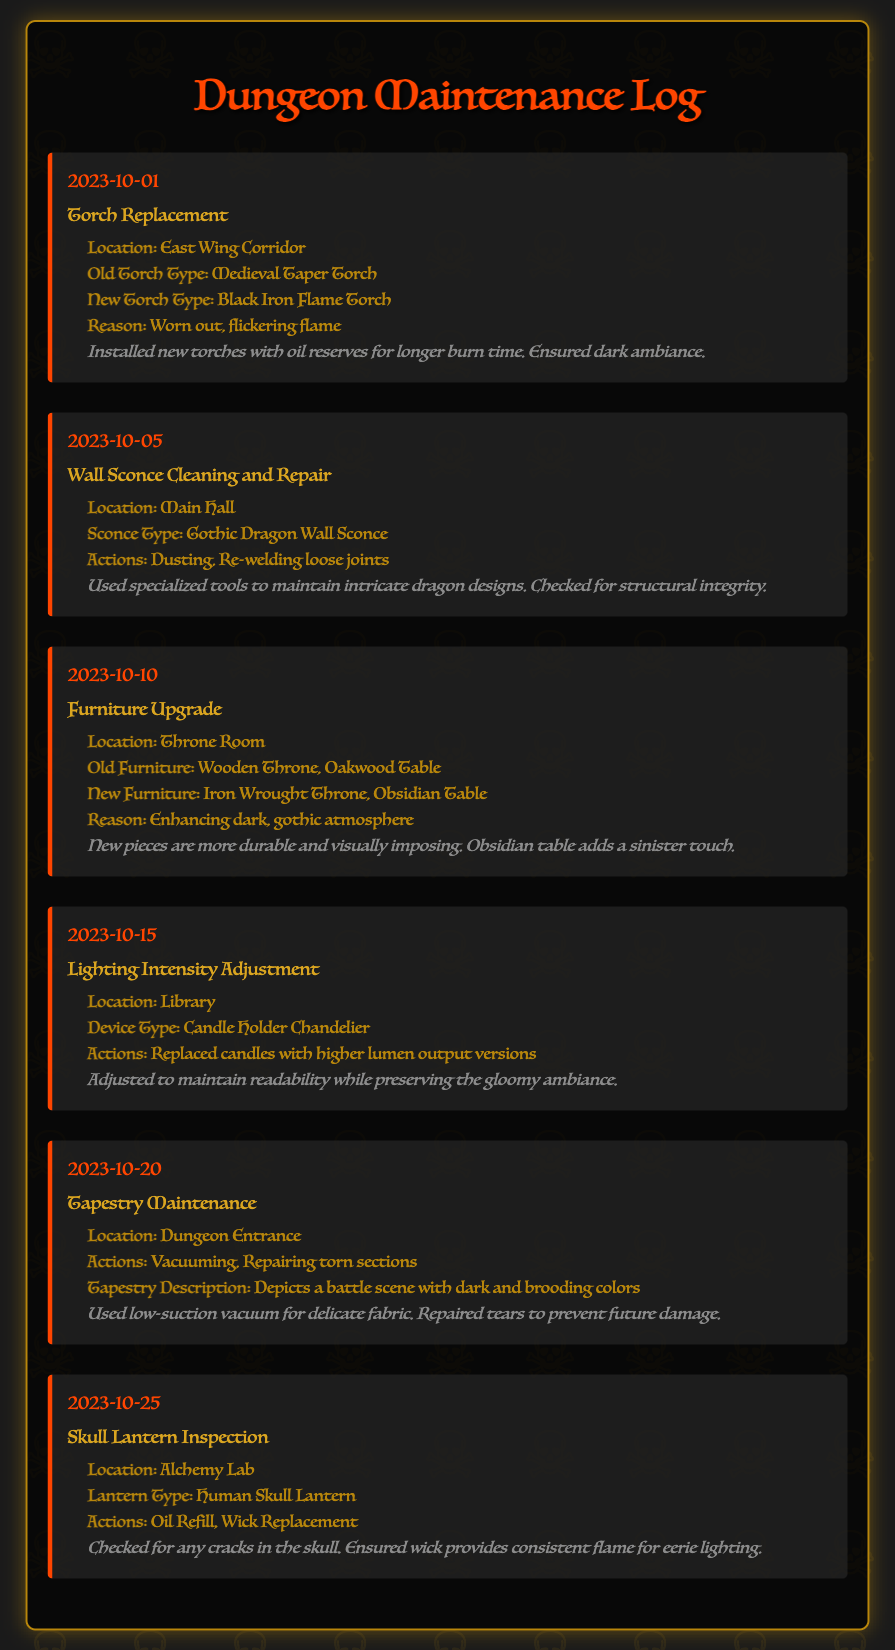What is the date of the torch replacement? The torch replacement is logged on October 1, 2023.
Answer: October 1, 2023 What type of new torch was installed in the East Wing Corridor? The new torch type installed is a Black Iron Flame Torch.
Answer: Black Iron Flame Torch How many maintenance activities were logged in total? There are six maintenance activities listed in the log.
Answer: Six What type of furniture was upgraded in the Throne Room? The furniture upgraded includes an Iron Wrought Throne and an Obsidian Table.
Answer: Iron Wrought Throne, Obsidian Table What action was taken during the skull lantern inspection? The actions included an oil refill and wick replacement.
Answer: Oil refill, wick replacement What was the reason for replacing the old torches? The reason for replacement was that the old torches were worn out and had a flickering flame.
Answer: Worn out, flickering flame What specific repair was done to the wall sconce in the Main Hall? The specific repair included re-welding loose joints.
Answer: Re-welding loose joints What maintenance action was performed on the tapestry? The maintenance action included vacuuming and repairing torn sections.
Answer: Vacuuming, repairing torn sections 